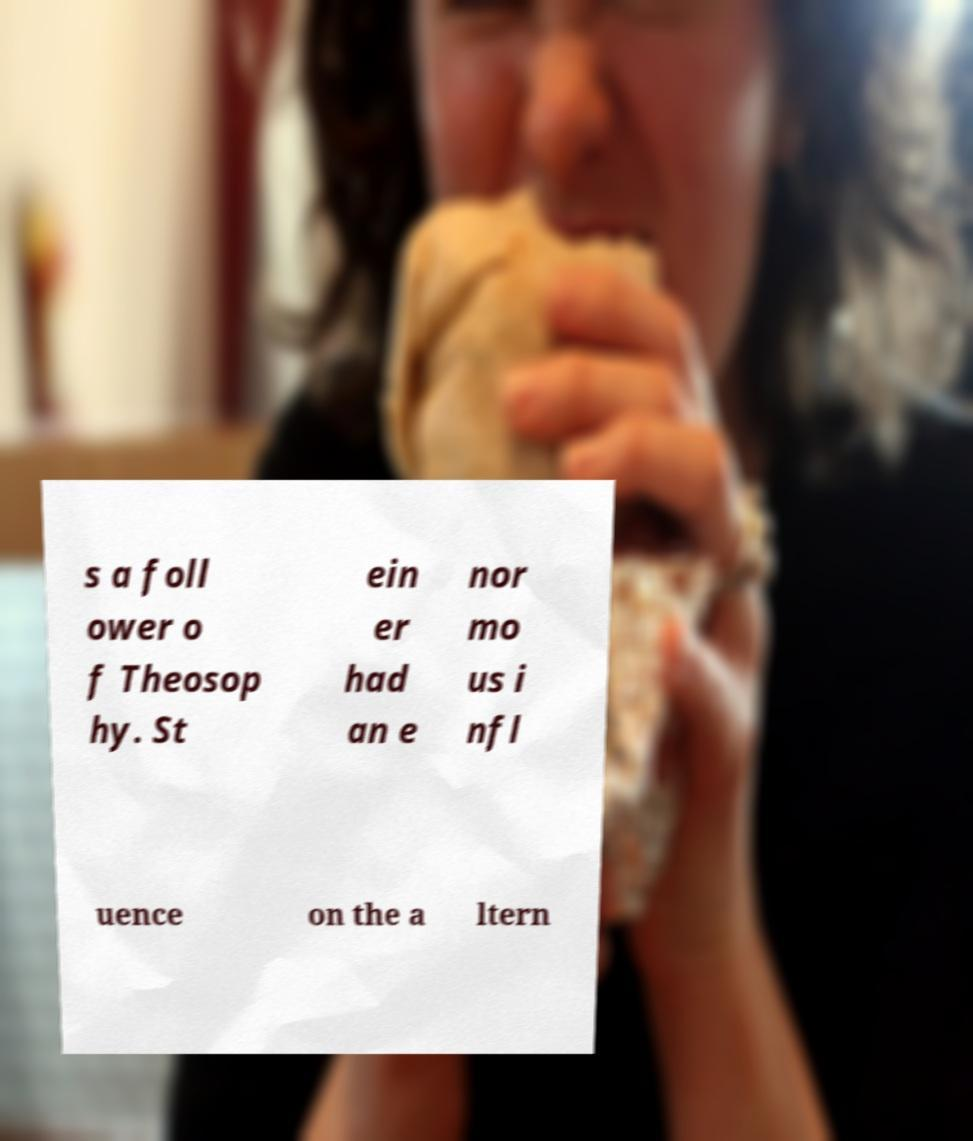I need the written content from this picture converted into text. Can you do that? s a foll ower o f Theosop hy. St ein er had an e nor mo us i nfl uence on the a ltern 